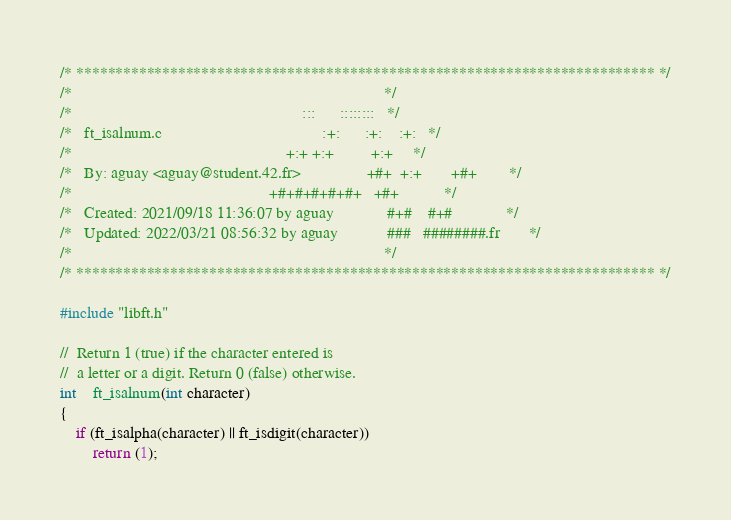Convert code to text. <code><loc_0><loc_0><loc_500><loc_500><_C_>/* ************************************************************************** */
/*                                                                            */
/*                                                        :::      ::::::::   */
/*   ft_isalnum.c                                       :+:      :+:    :+:   */
/*                                                    +:+ +:+         +:+     */
/*   By: aguay <aguay@student.42.fr>                +#+  +:+       +#+        */
/*                                                +#+#+#+#+#+   +#+           */
/*   Created: 2021/09/18 11:36:07 by aguay             #+#    #+#             */
/*   Updated: 2022/03/21 08:56:32 by aguay            ###   ########.fr       */
/*                                                                            */
/* ************************************************************************** */

#include "libft.h"

//	Return 1 (true) if the character entered is
//	a letter or a digit. Return 0 (false) otherwise.
int	ft_isalnum(int character)
{
	if (ft_isalpha(character) || ft_isdigit(character))
		return (1);</code> 